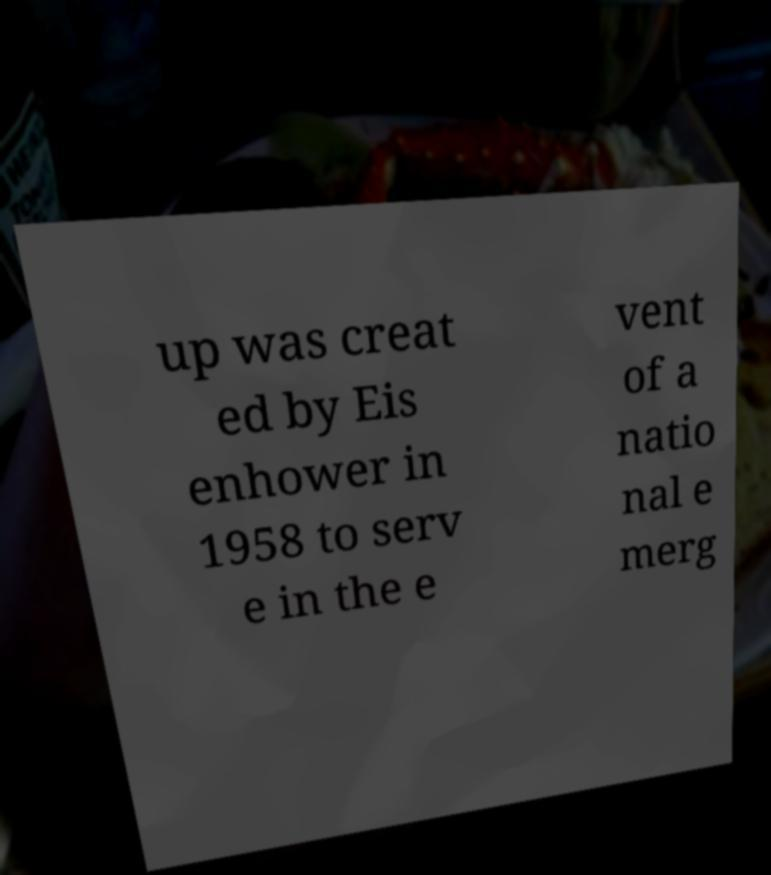Could you extract and type out the text from this image? up was creat ed by Eis enhower in 1958 to serv e in the e vent of a natio nal e merg 